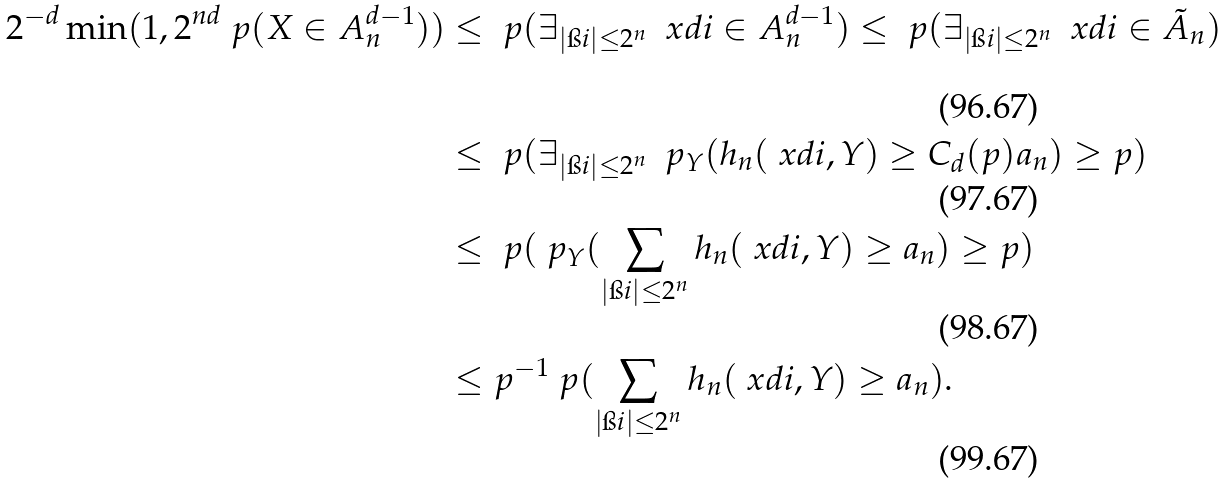<formula> <loc_0><loc_0><loc_500><loc_500>2 ^ { - d } \min ( 1 , 2 ^ { n d } \ p ( X \in A _ { n } ^ { d - 1 } ) ) & \leq \ p ( \exists _ { | \i i | \leq 2 ^ { n } } \ \ x d i \in A _ { n } ^ { d - 1 } ) \leq \ p ( \exists _ { | \i i | \leq 2 ^ { n } } \ \ x d i \in \tilde { A } _ { n } ) \\ & \leq \ p ( \exists _ { | \i i | \leq 2 ^ { n } } \ \ p _ { Y } ( h _ { n } ( \ x d i , Y ) \geq C _ { d } ( p ) a _ { n } ) \geq p ) \\ & \leq \ p ( \ p _ { Y } ( \sum _ { | \i i | \leq 2 ^ { n } } h _ { n } ( \ x d i , Y ) \geq a _ { n } ) \geq p ) \\ & \leq p ^ { - 1 } \ p ( \sum _ { | \i i | \leq 2 ^ { n } } h _ { n } ( \ x d i , Y ) \geq a _ { n } ) .</formula> 